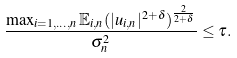<formula> <loc_0><loc_0><loc_500><loc_500>\frac { \max _ { i = 1 , \hdots , n } \mathbb { E } _ { i , n } ( | u _ { i , n } | ^ { 2 + \delta } ) ^ { \frac { 2 } { 2 + \delta } } } { \sigma _ { n } ^ { 2 } } \leq \tau .</formula> 